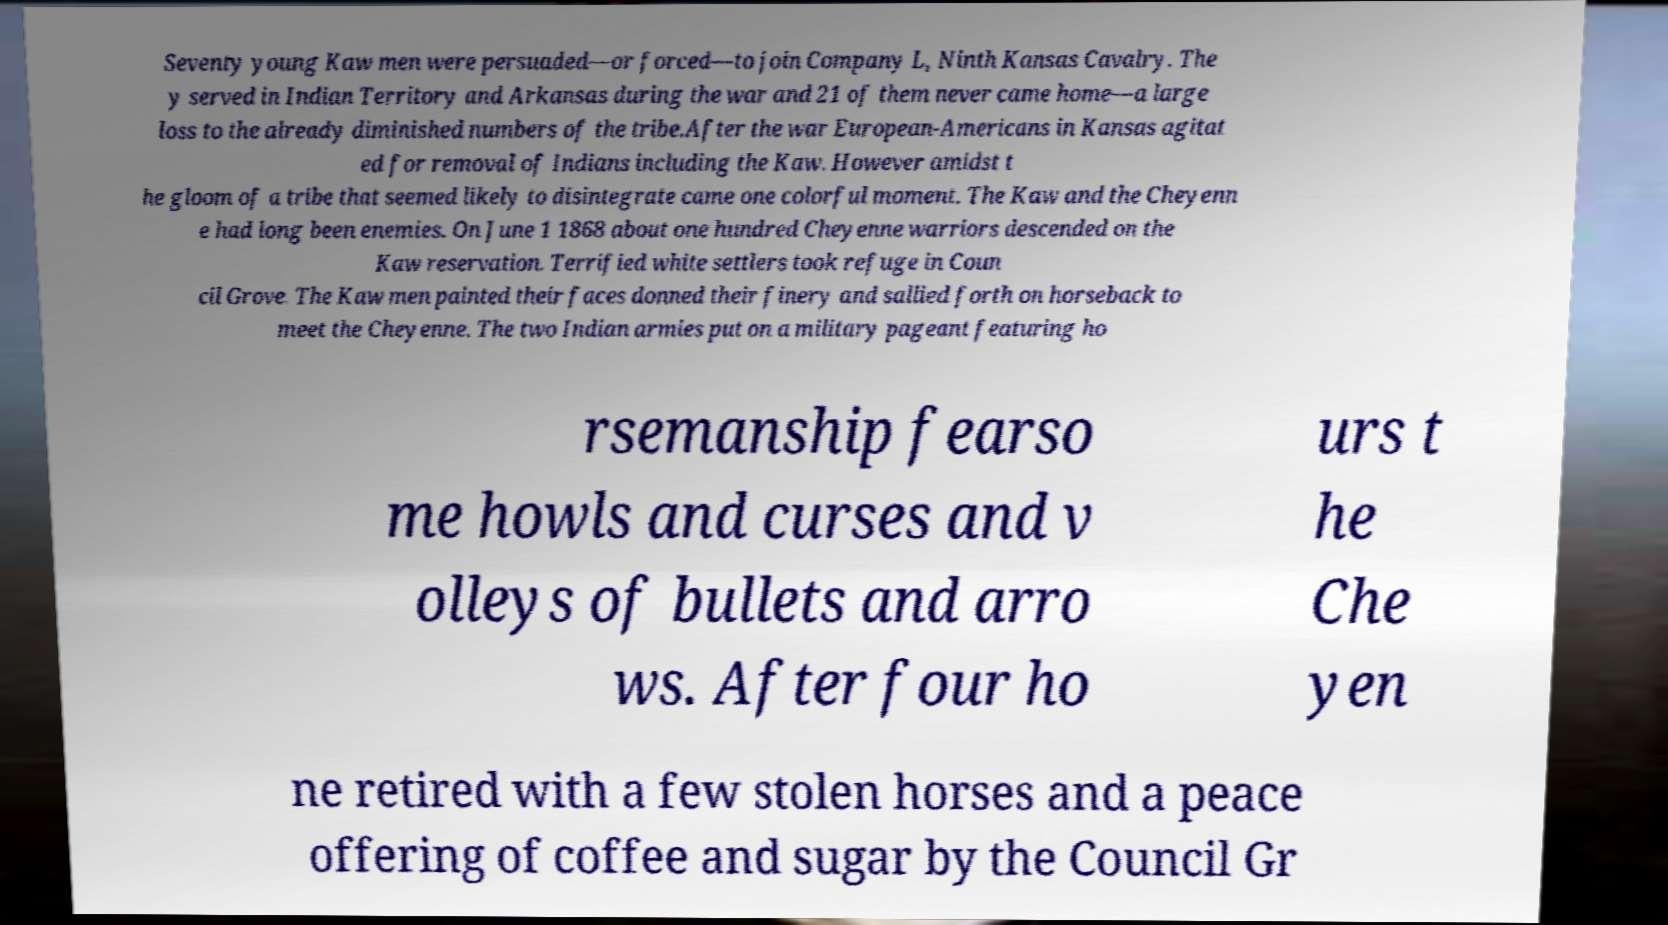Can you read and provide the text displayed in the image?This photo seems to have some interesting text. Can you extract and type it out for me? Seventy young Kaw men were persuaded—or forced—to join Company L, Ninth Kansas Cavalry. The y served in Indian Territory and Arkansas during the war and 21 of them never came home—a large loss to the already diminished numbers of the tribe.After the war European-Americans in Kansas agitat ed for removal of Indians including the Kaw. However amidst t he gloom of a tribe that seemed likely to disintegrate came one colorful moment. The Kaw and the Cheyenn e had long been enemies. On June 1 1868 about one hundred Cheyenne warriors descended on the Kaw reservation. Terrified white settlers took refuge in Coun cil Grove. The Kaw men painted their faces donned their finery and sallied forth on horseback to meet the Cheyenne. The two Indian armies put on a military pageant featuring ho rsemanship fearso me howls and curses and v olleys of bullets and arro ws. After four ho urs t he Che yen ne retired with a few stolen horses and a peace offering of coffee and sugar by the Council Gr 